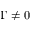<formula> <loc_0><loc_0><loc_500><loc_500>\Gamma \neq 0</formula> 